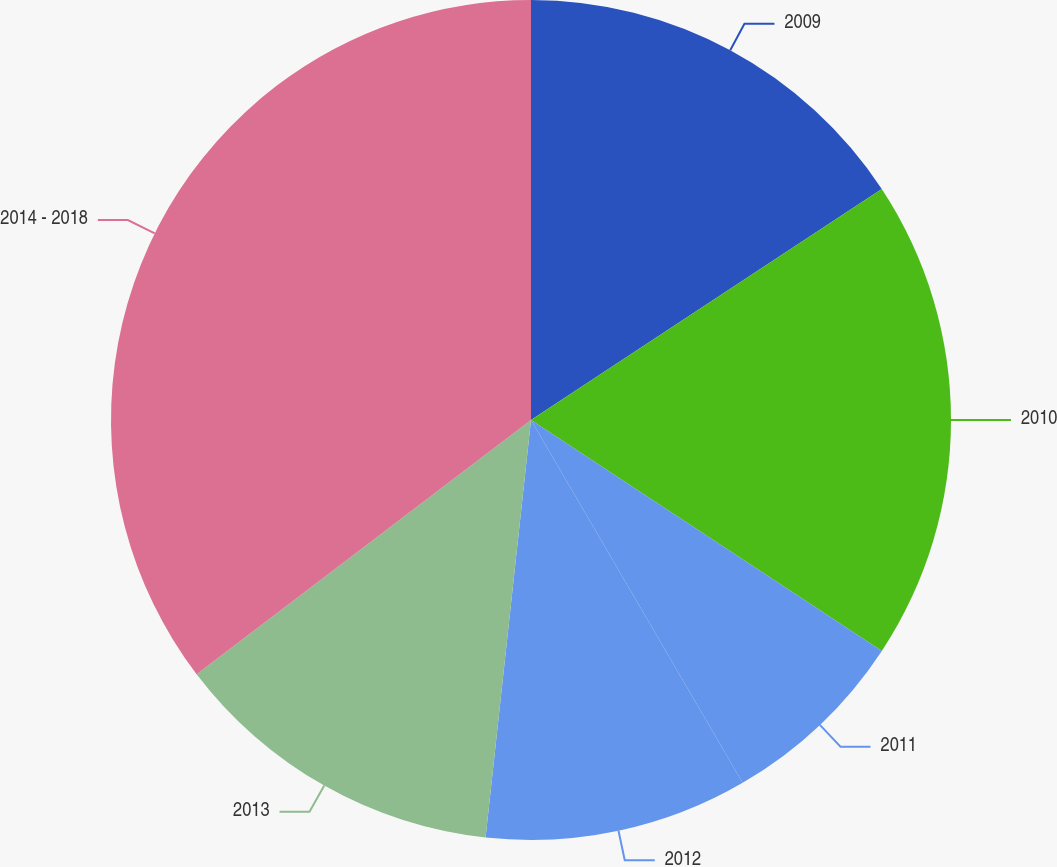Convert chart to OTSL. <chart><loc_0><loc_0><loc_500><loc_500><pie_chart><fcel>2009<fcel>2010<fcel>2011<fcel>2012<fcel>2013<fcel>2014 - 2018<nl><fcel>15.73%<fcel>18.53%<fcel>7.33%<fcel>10.13%<fcel>12.93%<fcel>35.34%<nl></chart> 